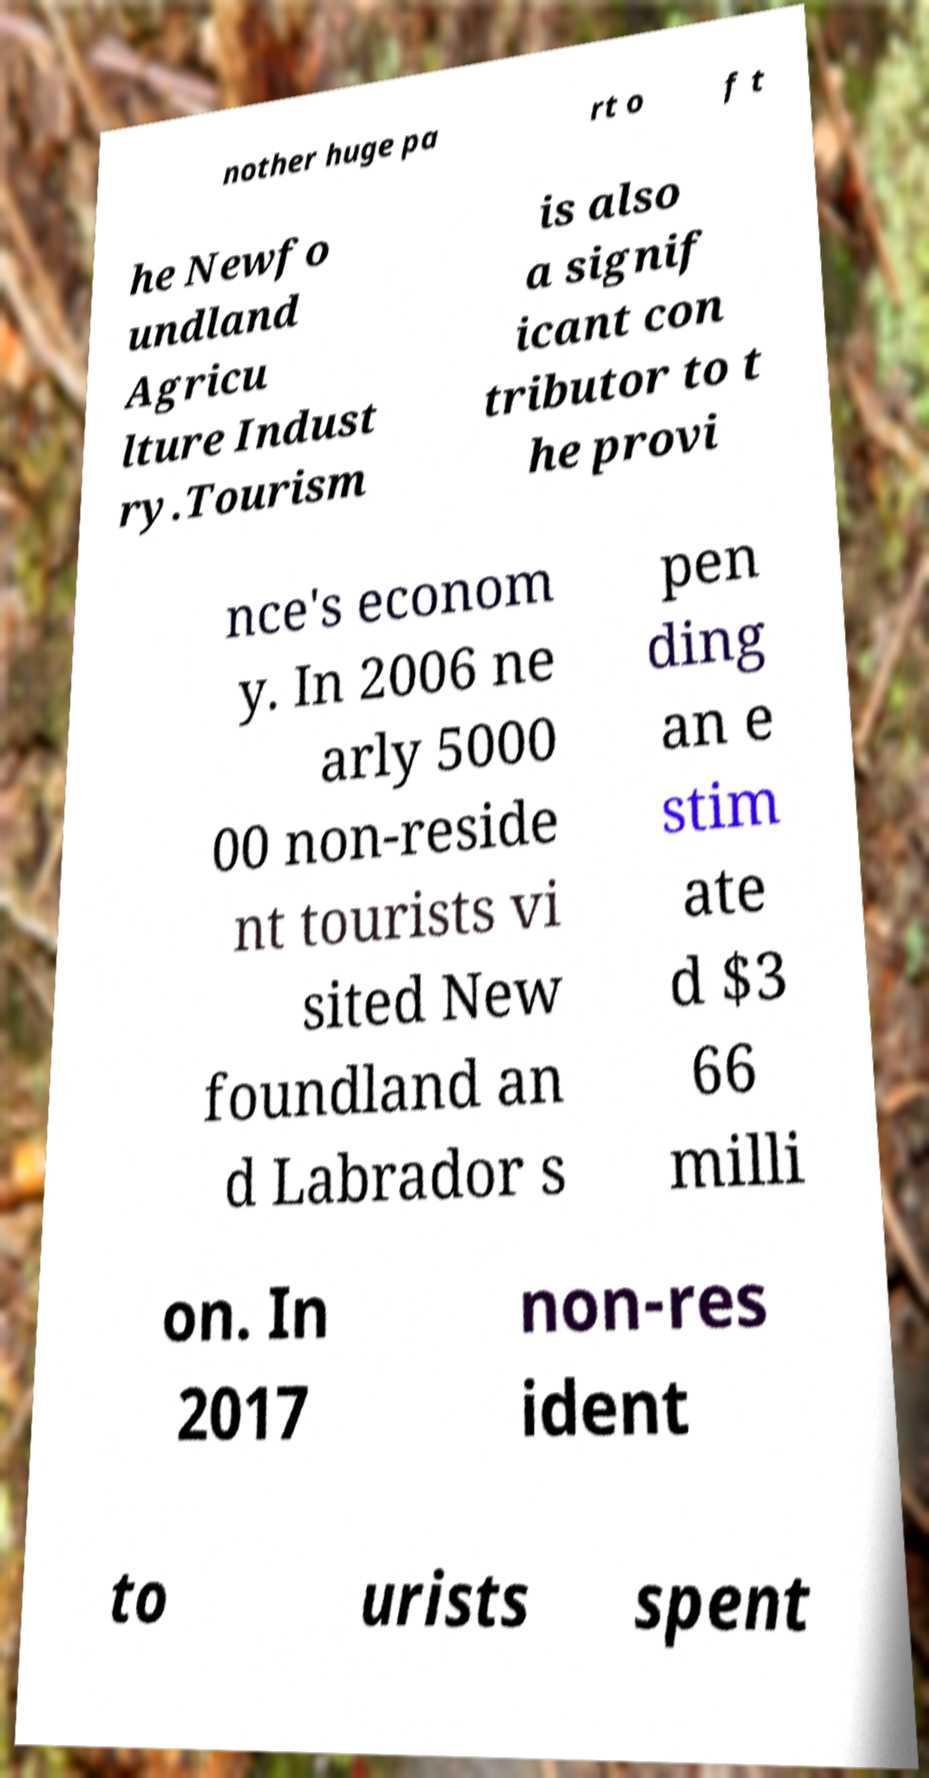Please read and relay the text visible in this image. What does it say? nother huge pa rt o f t he Newfo undland Agricu lture Indust ry.Tourism is also a signif icant con tributor to t he provi nce's econom y. In 2006 ne arly 5000 00 non-reside nt tourists vi sited New foundland an d Labrador s pen ding an e stim ate d $3 66 milli on. In 2017 non-res ident to urists spent 